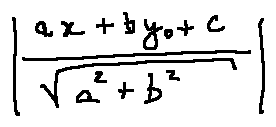Convert formula to latex. <formula><loc_0><loc_0><loc_500><loc_500>| \frac { a x _ { 0 } + b y _ { 0 } + c } { \sqrt { a ^ { 2 } + b ^ { 2 } } } |</formula> 